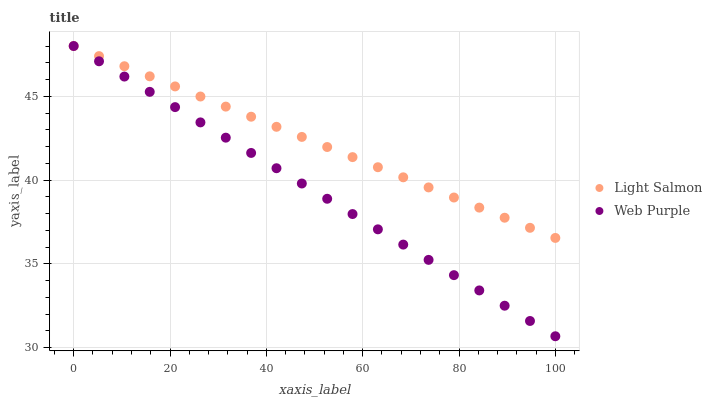Does Web Purple have the minimum area under the curve?
Answer yes or no. Yes. Does Light Salmon have the maximum area under the curve?
Answer yes or no. Yes. Does Web Purple have the maximum area under the curve?
Answer yes or no. No. Is Light Salmon the smoothest?
Answer yes or no. Yes. Is Web Purple the roughest?
Answer yes or no. Yes. Is Web Purple the smoothest?
Answer yes or no. No. Does Web Purple have the lowest value?
Answer yes or no. Yes. Does Web Purple have the highest value?
Answer yes or no. Yes. Does Light Salmon intersect Web Purple?
Answer yes or no. Yes. Is Light Salmon less than Web Purple?
Answer yes or no. No. Is Light Salmon greater than Web Purple?
Answer yes or no. No. 